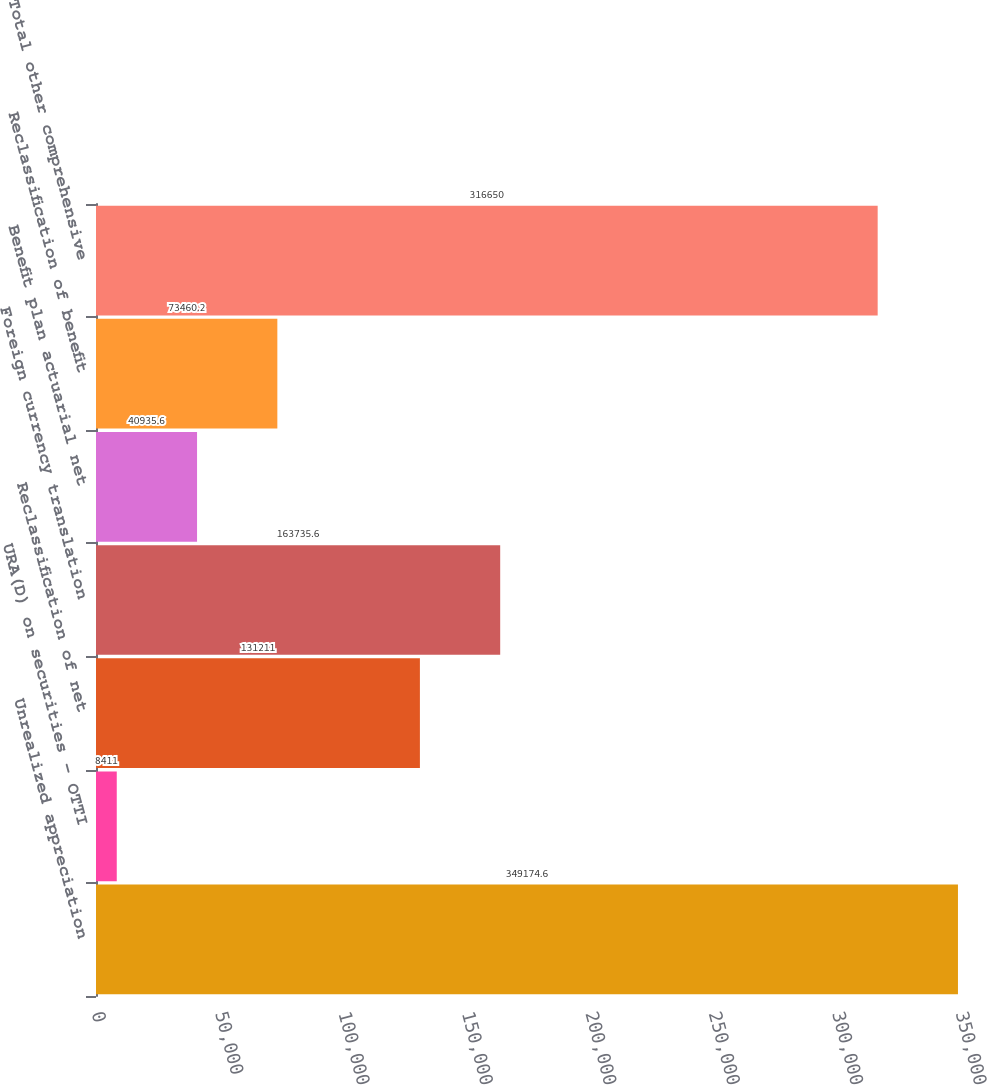<chart> <loc_0><loc_0><loc_500><loc_500><bar_chart><fcel>Unrealized appreciation<fcel>URA(D) on securities - OTTI<fcel>Reclassification of net<fcel>Foreign currency translation<fcel>Benefit plan actuarial net<fcel>Reclassification of benefit<fcel>Total other comprehensive<nl><fcel>349175<fcel>8411<fcel>131211<fcel>163736<fcel>40935.6<fcel>73460.2<fcel>316650<nl></chart> 